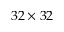<formula> <loc_0><loc_0><loc_500><loc_500>3 2 \times 3 2</formula> 